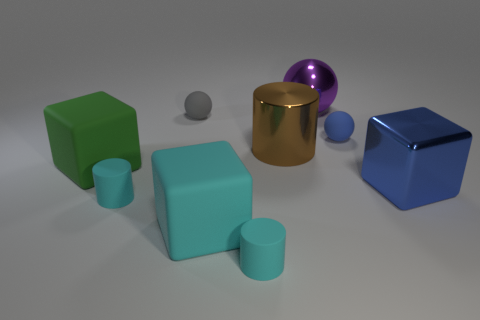There is a thing that is the same color as the metallic cube; what size is it? The object that shares the color with the metallic cube is a small sphere roughly the size of a table tennis ball. 